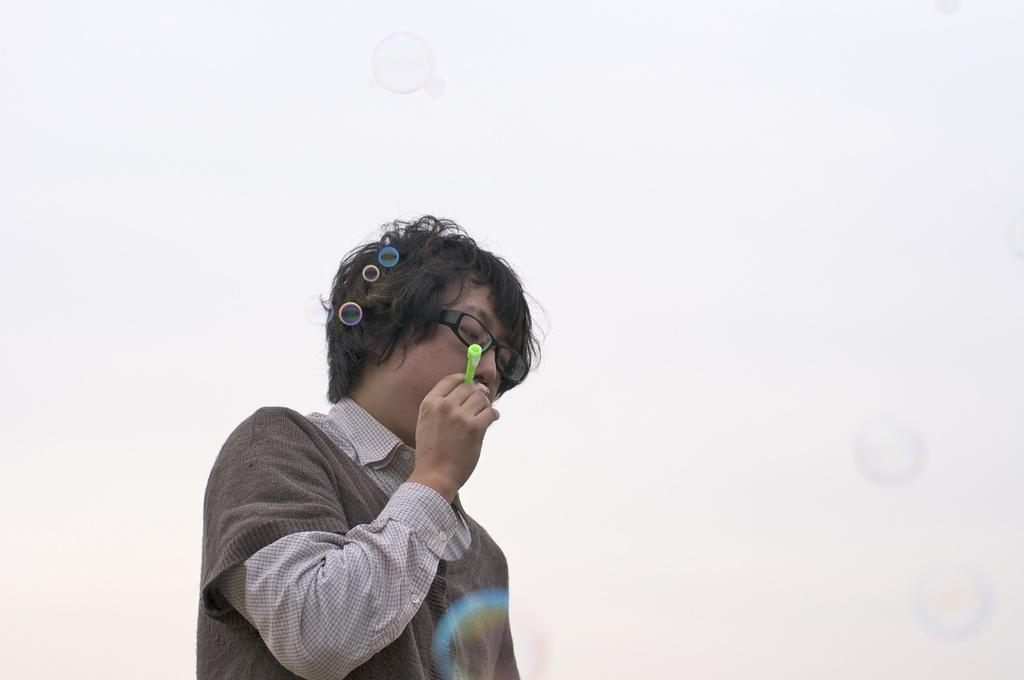Who is the main subject in the image? There is a boy in the image. What is the boy wearing? The boy is wearing spectacles. What is the boy holding in his hand? The boy is holding an object in his hand. What can be seen in the background of the image? There are water bubbles in the background of the image. What letters can be seen on the boy's shirt in the image? There is no information about the boy's shirt or any letters on it in the provided facts. 